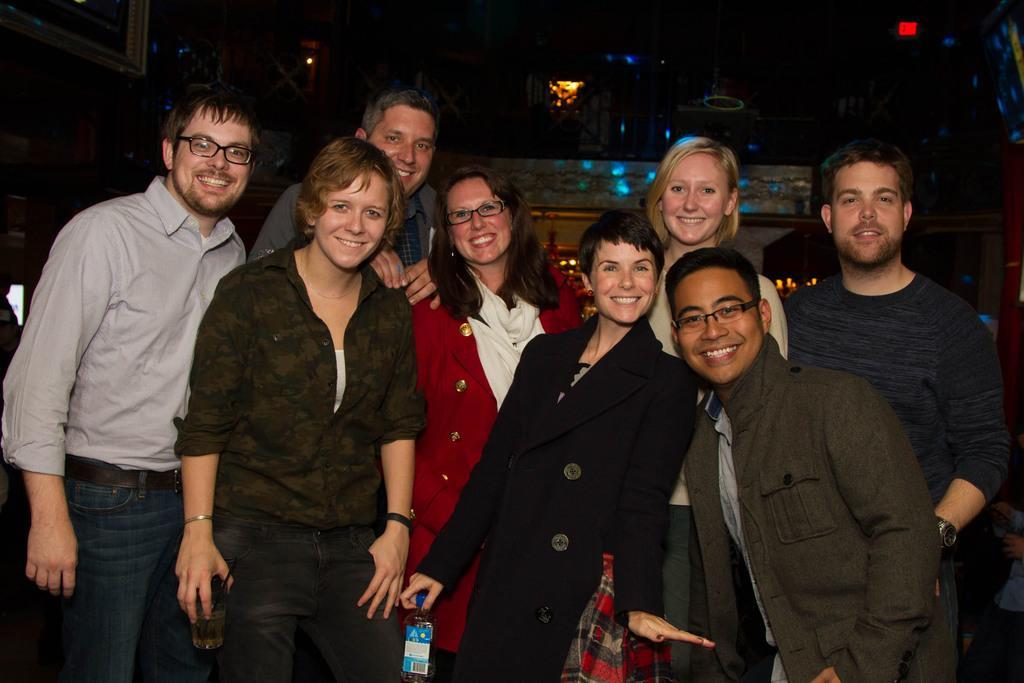Could you give a brief overview of what you see in this image? In the image we can see there are people standing, wearing clothes and they are smiling, and some of them are wearing spectacles and holding objects in hands. Here we can see the light and the background is dark. 